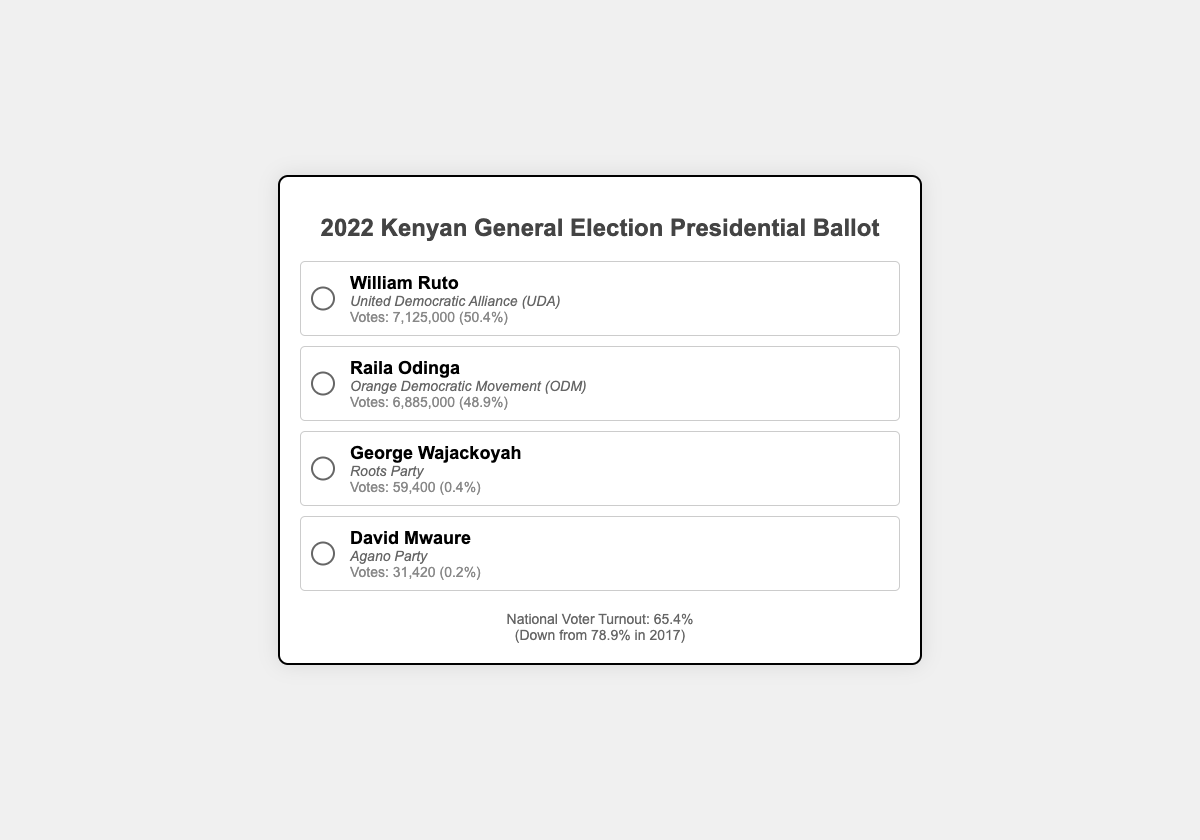What was the voter turnout percentage? The voter turnout percentage is explicitly stated in the document as 65.4%.
Answer: 65.4% Who received the most votes? The candidate with the most votes listed is William Ruto with 7,125,000 votes.
Answer: William Ruto Which party did Raila Odinga represent? The party representing Raila Odinga is provided as the Orange Democratic Movement (ODM).
Answer: Orange Democratic Movement (ODM) How many votes did George Wajackoyah receive? The document provides the number of votes received by George Wajackoyah as 59,400 votes.
Answer: 59,400 What was the voter turnout in 2017? The previous voter turnout in 2017 is mentioned as 78.9%.
Answer: 78.9% Which candidate received the least votes? The document indicates that David Mwaure received the least votes at 31,420.
Answer: David Mwaure What percentage of votes did William Ruto get? The document specifies that William Ruto received 50.4% of the votes.
Answer: 50.4% How many candidates are listed on the ballot? The document shows a total of four candidates listed on the ballot.
Answer: Four candidates What was the turnout change from 2017 to 2022? The document states the turnout decreased from 78.9% in 2017 to 65.4% in 2022, indicating a drop.
Answer: Down 